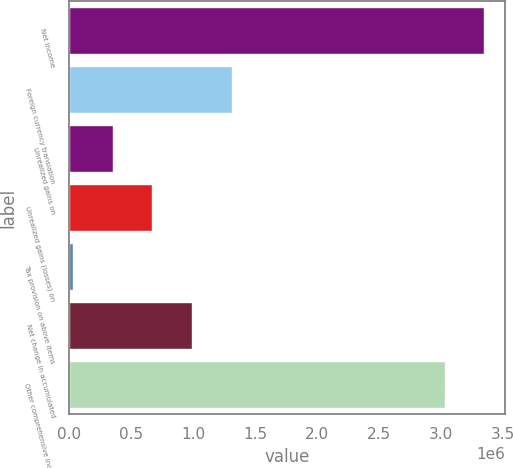Convert chart. <chart><loc_0><loc_0><loc_500><loc_500><bar_chart><fcel>Net income<fcel>Foreign currency translation<fcel>Unrealized gains on<fcel>Unrealized gains (losses) on<fcel>Tax provision on above items<fcel>Net change in accumulated<fcel>Other comprehensive income<nl><fcel>3.34688e+06<fcel>1.31336e+06<fcel>355347<fcel>674685<fcel>36009<fcel>994022<fcel>3.02754e+06<nl></chart> 